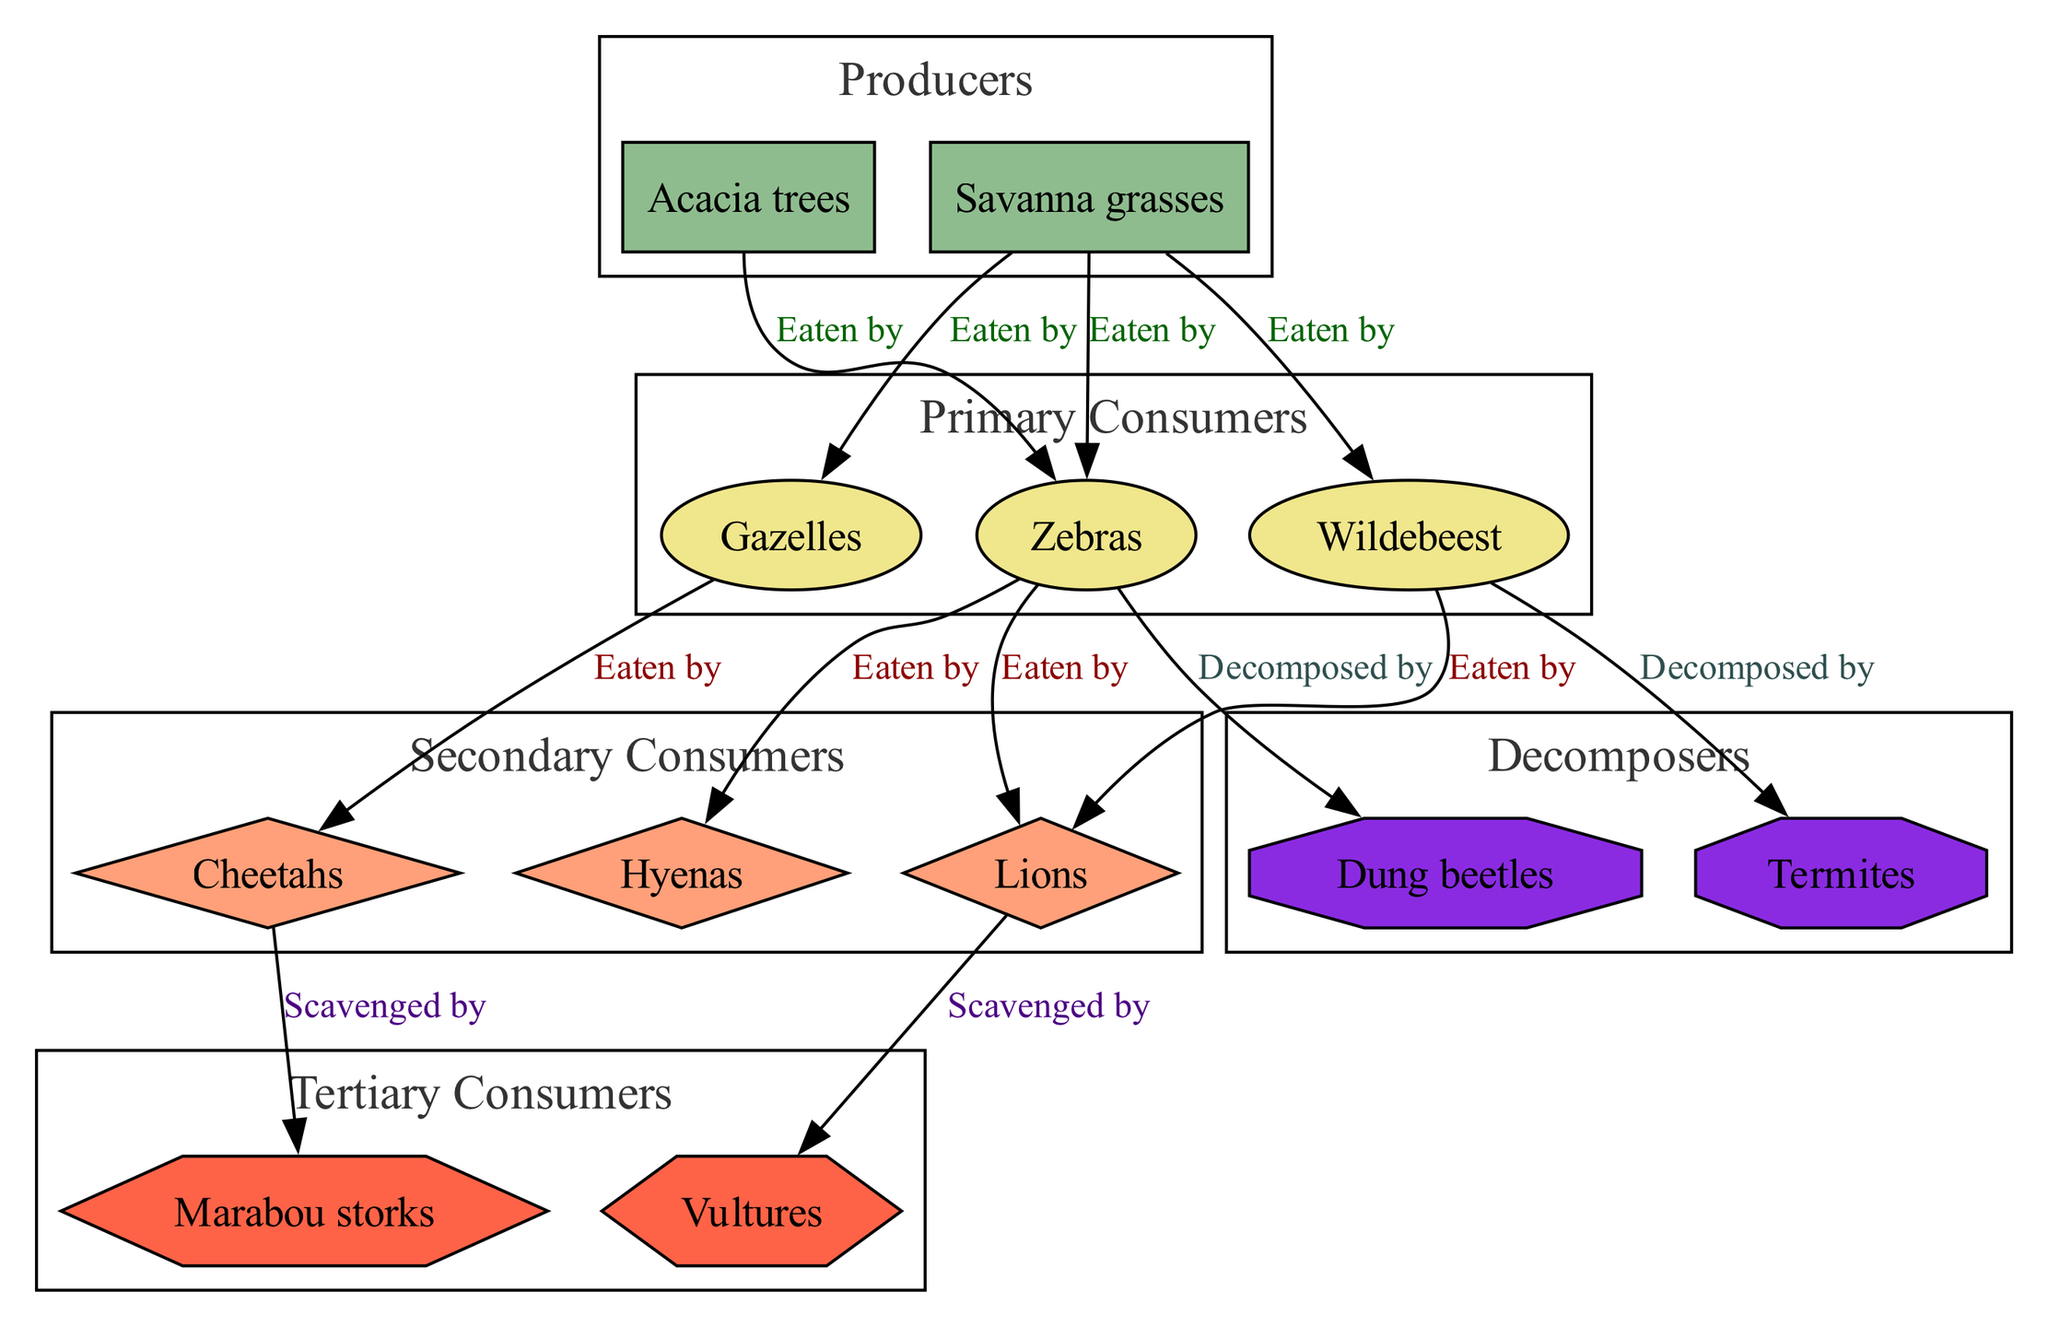What are the producers in the diagram? The producers are the first level in the food chain, providing energy for the consumers. In this diagram, the producers are "Acacia trees" and "Savanna grasses."
Answer: Acacia trees, Savanna grasses How many primary consumers are there? To find this, we count the number of primary consumers listed in the diagram. The primary consumers are "Zebras," "Wildebeest," and "Gazelles," totaling three consumers.
Answer: 3 Who are the secondary consumers? The secondary consumers are animals that eat the primary consumers. In this diagram, they include "Lions," "Cheetahs," and "Hyenas."
Answer: Lions, Cheetahs, Hyenas Which consumer is eaten by Vultures? According to the relationships in the diagram, "Lions" are scavenged by "Vultures," indicating Lions are the ones associated with Vultures.
Answer: Lions What do Dung beetles decompose? To answer this, we look for the relationship associated with Dung beetles in the diagram. They are indicated to decompose "Zebras."
Answer: Zebras What is the relationship between Hyenas and Zebras? The diagram shows that Hyenas "Eaten by" Zebras, illustrating how they fit into the food chain's consumer hierarchy.
Answer: Eaten by How many total relationships are represented in the diagram? We analyze the relationships present in the diagram, which include "Eaten by," "Scavenged by," and "Decomposed by." By counting each connection, we find there are eight distinct relationships.
Answer: 8 Who are the tertiary consumers? Tertiary consumers are the ones that eat secondary consumers in the food chain. In this case, the tertiary consumers listed are "Vultures" and "Marabou storks."
Answer: Vultures, Marabou storks What unites all decomposers in the food chain? The common trait of decomposers in this food chain diagram is that they break down dead organic matter, specifically shown to be associated with "Dung beetles" and "Termites."
Answer: Dung beetles, Termites 